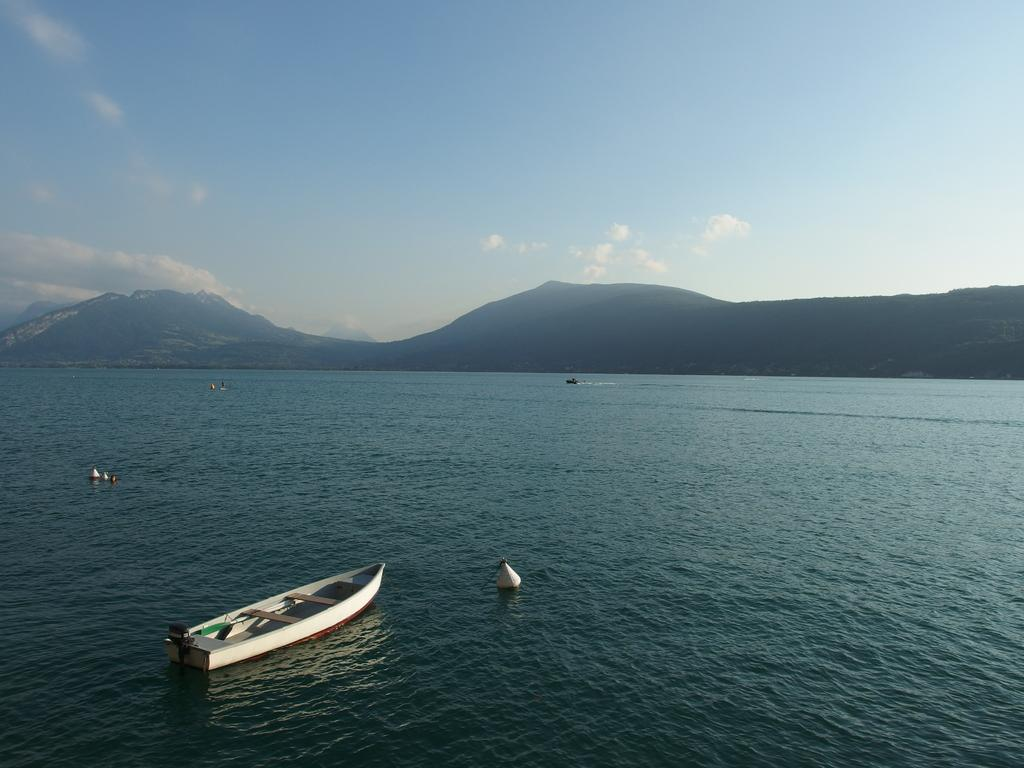What is the main subject of the image? The main subject of the image is a boat. Where is the boat located? The boat is on the water. What can be seen in the background of the image? There are hills visible in the background of the image. What is visible in the sky in the image? The sky is visible in the image, and clouds are present. What type of pleasure can be seen operating the boat in the image? There is no person or entity operating the boat in the image, and therefore no pleasure can be associated with it. 